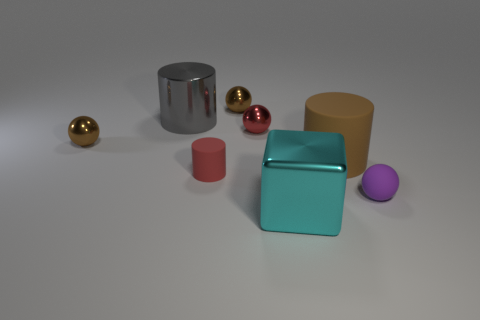What size is the object that is the same color as the tiny cylinder?
Your response must be concise. Small. How many small shiny objects have the same color as the tiny matte cylinder?
Offer a terse response. 1. What material is the large cylinder that is on the left side of the large brown rubber cylinder?
Your response must be concise. Metal. Is there a gray thing of the same shape as the tiny red matte thing?
Your answer should be compact. Yes. What number of other objects are there of the same shape as the large gray shiny object?
Your answer should be compact. 2. Is the shape of the big brown thing the same as the big shiny object that is behind the small red matte object?
Offer a terse response. Yes. What material is the other large thing that is the same shape as the brown rubber object?
Give a very brief answer. Metal. What number of tiny things are either purple rubber spheres or red cylinders?
Make the answer very short. 2. Is the number of gray things that are right of the large gray shiny cylinder less than the number of things that are in front of the large brown object?
Provide a succinct answer. Yes. What number of things are matte balls or small metallic blocks?
Keep it short and to the point. 1. 